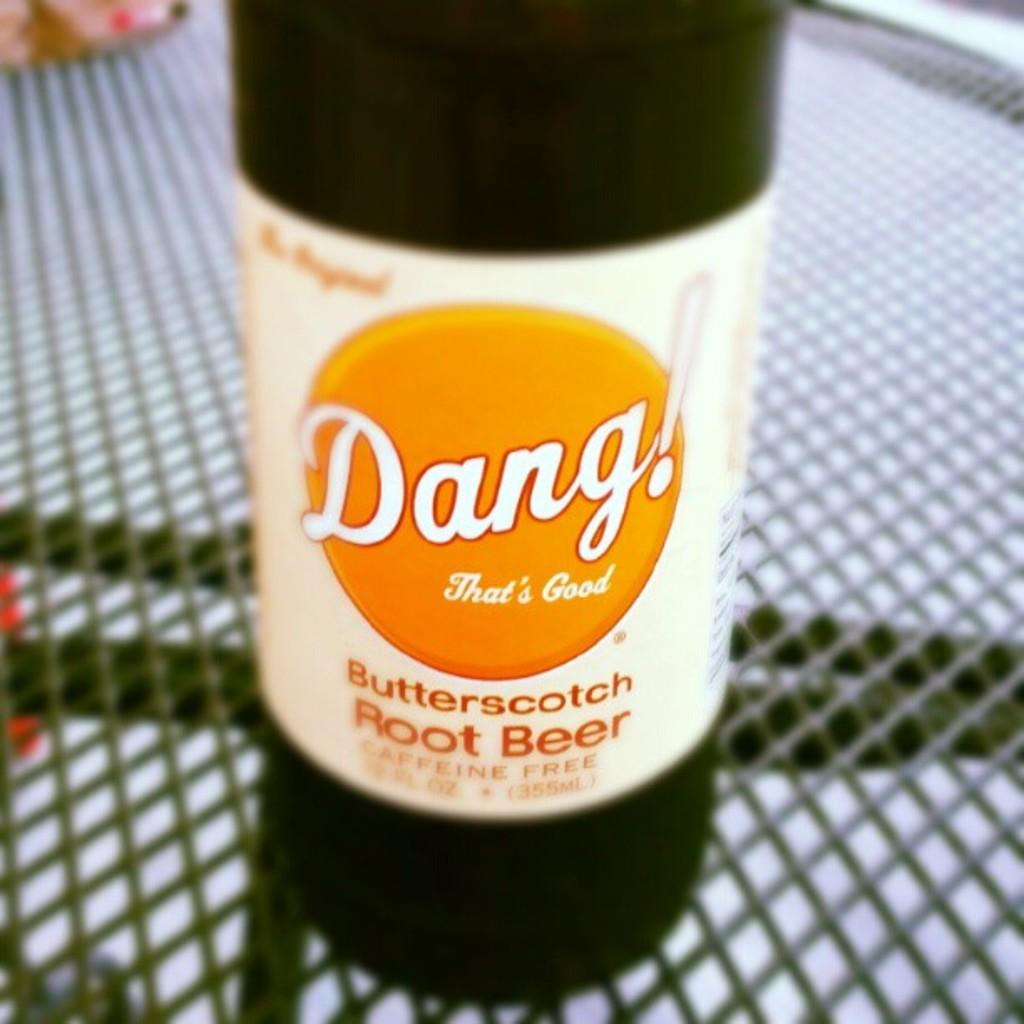<image>
Provide a brief description of the given image. A bottle of Dang! That's Good Butterscotch Root Beer 